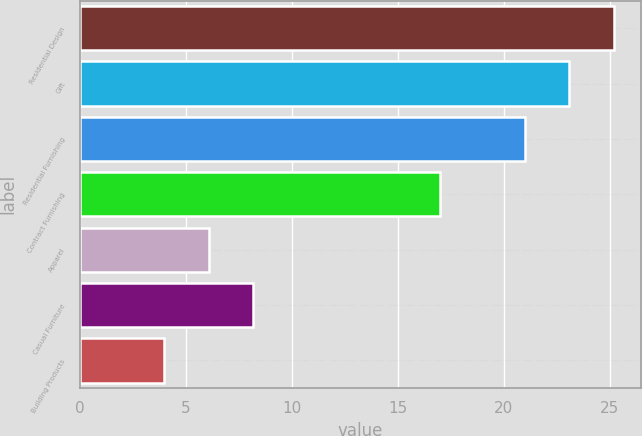Convert chart. <chart><loc_0><loc_0><loc_500><loc_500><bar_chart><fcel>Residential Design<fcel>Gift<fcel>Residential Furnishing<fcel>Contract Furnishing<fcel>Apparel<fcel>Casual Furniture<fcel>Building Products<nl><fcel>25.2<fcel>23.1<fcel>21<fcel>17<fcel>6.1<fcel>8.2<fcel>4<nl></chart> 